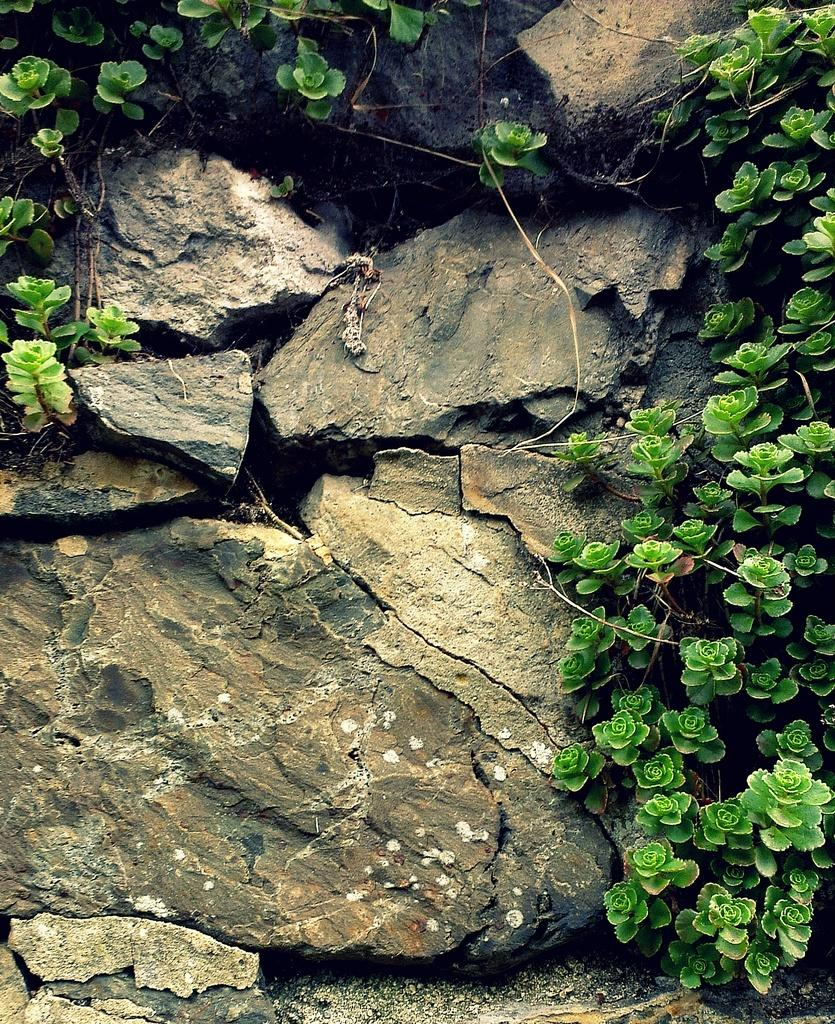What type of natural elements can be seen in the image? There are stones and plants in the image. What is the color of the plants in the image? The plants in the image are green in color. Where is the sister of the person taking the picture in the image? There is no person taking the picture or any sister present in the image. What type of birds can be seen flying in the image? There are no birds, including geese, present in the image. 